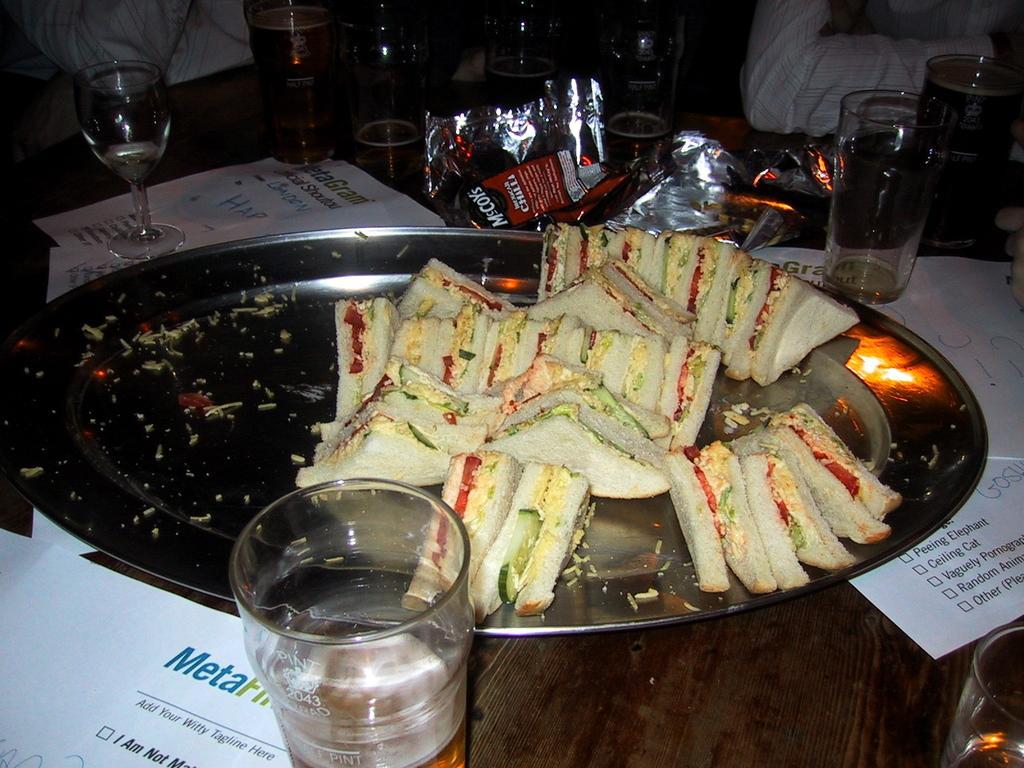How would you summarize this image in a sentence or two? In this image there is a table on which there are some papers and also plate with so many sandwiches around that there are some glasses with drinks and some wrappers also there are people sitting around the table. 